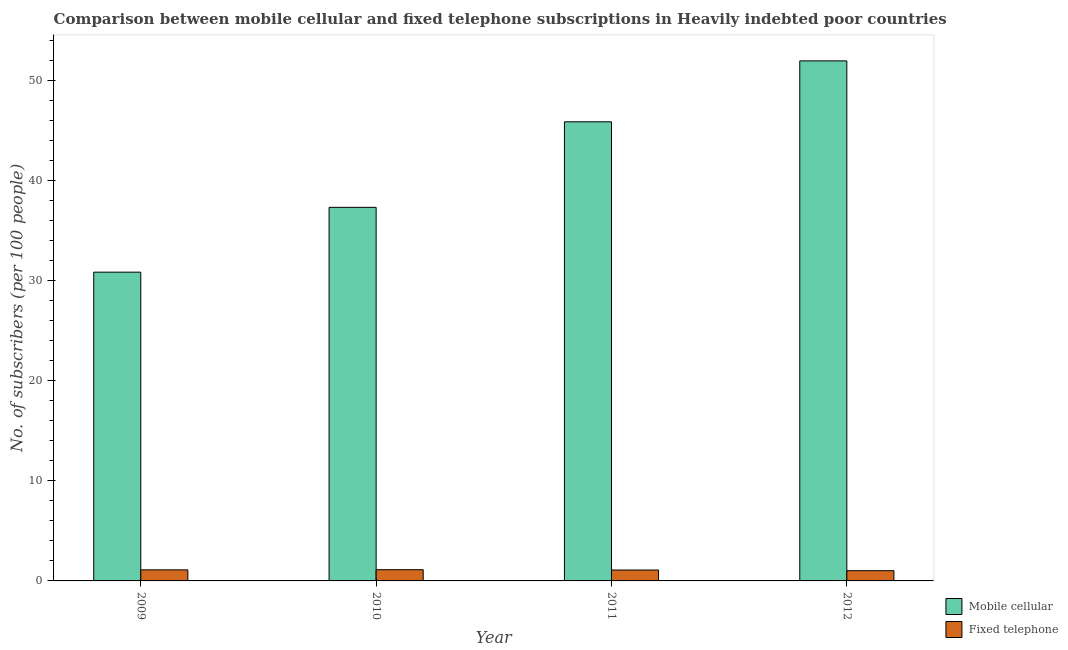How many different coloured bars are there?
Offer a terse response. 2. Are the number of bars per tick equal to the number of legend labels?
Offer a terse response. Yes. How many bars are there on the 1st tick from the left?
Give a very brief answer. 2. How many bars are there on the 3rd tick from the right?
Your response must be concise. 2. What is the label of the 4th group of bars from the left?
Provide a short and direct response. 2012. In how many cases, is the number of bars for a given year not equal to the number of legend labels?
Ensure brevity in your answer.  0. What is the number of fixed telephone subscribers in 2009?
Your answer should be compact. 1.11. Across all years, what is the maximum number of mobile cellular subscribers?
Your answer should be very brief. 51.99. Across all years, what is the minimum number of mobile cellular subscribers?
Provide a succinct answer. 30.87. In which year was the number of mobile cellular subscribers maximum?
Your answer should be very brief. 2012. What is the total number of mobile cellular subscribers in the graph?
Your answer should be very brief. 166.1. What is the difference between the number of fixed telephone subscribers in 2010 and that in 2011?
Provide a succinct answer. 0.03. What is the difference between the number of mobile cellular subscribers in 2012 and the number of fixed telephone subscribers in 2011?
Provide a short and direct response. 6.09. What is the average number of mobile cellular subscribers per year?
Your answer should be compact. 41.53. In the year 2011, what is the difference between the number of fixed telephone subscribers and number of mobile cellular subscribers?
Your response must be concise. 0. What is the ratio of the number of mobile cellular subscribers in 2009 to that in 2012?
Provide a succinct answer. 0.59. Is the difference between the number of fixed telephone subscribers in 2009 and 2012 greater than the difference between the number of mobile cellular subscribers in 2009 and 2012?
Offer a very short reply. No. What is the difference between the highest and the second highest number of fixed telephone subscribers?
Provide a short and direct response. 0.02. What is the difference between the highest and the lowest number of fixed telephone subscribers?
Give a very brief answer. 0.1. In how many years, is the number of mobile cellular subscribers greater than the average number of mobile cellular subscribers taken over all years?
Offer a very short reply. 2. What does the 1st bar from the left in 2010 represents?
Your answer should be very brief. Mobile cellular. What does the 2nd bar from the right in 2009 represents?
Make the answer very short. Mobile cellular. What is the difference between two consecutive major ticks on the Y-axis?
Your answer should be very brief. 10. Are the values on the major ticks of Y-axis written in scientific E-notation?
Provide a succinct answer. No. Does the graph contain any zero values?
Provide a short and direct response. No. Does the graph contain grids?
Your answer should be very brief. No. Where does the legend appear in the graph?
Your answer should be compact. Bottom right. How many legend labels are there?
Ensure brevity in your answer.  2. How are the legend labels stacked?
Your answer should be very brief. Vertical. What is the title of the graph?
Provide a short and direct response. Comparison between mobile cellular and fixed telephone subscriptions in Heavily indebted poor countries. Does "Highest 20% of population" appear as one of the legend labels in the graph?
Offer a terse response. No. What is the label or title of the Y-axis?
Offer a terse response. No. of subscribers (per 100 people). What is the No. of subscribers (per 100 people) of Mobile cellular in 2009?
Offer a terse response. 30.87. What is the No. of subscribers (per 100 people) in Fixed telephone in 2009?
Your response must be concise. 1.11. What is the No. of subscribers (per 100 people) in Mobile cellular in 2010?
Your response must be concise. 37.35. What is the No. of subscribers (per 100 people) of Fixed telephone in 2010?
Give a very brief answer. 1.12. What is the No. of subscribers (per 100 people) of Mobile cellular in 2011?
Your answer should be very brief. 45.9. What is the No. of subscribers (per 100 people) of Fixed telephone in 2011?
Offer a very short reply. 1.09. What is the No. of subscribers (per 100 people) in Mobile cellular in 2012?
Your answer should be compact. 51.99. What is the No. of subscribers (per 100 people) of Fixed telephone in 2012?
Provide a short and direct response. 1.02. Across all years, what is the maximum No. of subscribers (per 100 people) of Mobile cellular?
Make the answer very short. 51.99. Across all years, what is the maximum No. of subscribers (per 100 people) of Fixed telephone?
Provide a succinct answer. 1.12. Across all years, what is the minimum No. of subscribers (per 100 people) of Mobile cellular?
Give a very brief answer. 30.87. Across all years, what is the minimum No. of subscribers (per 100 people) in Fixed telephone?
Keep it short and to the point. 1.02. What is the total No. of subscribers (per 100 people) of Mobile cellular in the graph?
Give a very brief answer. 166.1. What is the total No. of subscribers (per 100 people) in Fixed telephone in the graph?
Provide a succinct answer. 4.34. What is the difference between the No. of subscribers (per 100 people) in Mobile cellular in 2009 and that in 2010?
Give a very brief answer. -6.48. What is the difference between the No. of subscribers (per 100 people) in Fixed telephone in 2009 and that in 2010?
Provide a short and direct response. -0.02. What is the difference between the No. of subscribers (per 100 people) in Mobile cellular in 2009 and that in 2011?
Ensure brevity in your answer.  -15.03. What is the difference between the No. of subscribers (per 100 people) in Fixed telephone in 2009 and that in 2011?
Offer a very short reply. 0.02. What is the difference between the No. of subscribers (per 100 people) of Mobile cellular in 2009 and that in 2012?
Your response must be concise. -21.12. What is the difference between the No. of subscribers (per 100 people) in Fixed telephone in 2009 and that in 2012?
Offer a terse response. 0.08. What is the difference between the No. of subscribers (per 100 people) in Mobile cellular in 2010 and that in 2011?
Make the answer very short. -8.55. What is the difference between the No. of subscribers (per 100 people) in Fixed telephone in 2010 and that in 2011?
Keep it short and to the point. 0.03. What is the difference between the No. of subscribers (per 100 people) in Mobile cellular in 2010 and that in 2012?
Ensure brevity in your answer.  -14.64. What is the difference between the No. of subscribers (per 100 people) in Fixed telephone in 2010 and that in 2012?
Make the answer very short. 0.1. What is the difference between the No. of subscribers (per 100 people) of Mobile cellular in 2011 and that in 2012?
Make the answer very short. -6.09. What is the difference between the No. of subscribers (per 100 people) in Fixed telephone in 2011 and that in 2012?
Provide a succinct answer. 0.07. What is the difference between the No. of subscribers (per 100 people) of Mobile cellular in 2009 and the No. of subscribers (per 100 people) of Fixed telephone in 2010?
Provide a succinct answer. 29.75. What is the difference between the No. of subscribers (per 100 people) in Mobile cellular in 2009 and the No. of subscribers (per 100 people) in Fixed telephone in 2011?
Your answer should be very brief. 29.78. What is the difference between the No. of subscribers (per 100 people) in Mobile cellular in 2009 and the No. of subscribers (per 100 people) in Fixed telephone in 2012?
Give a very brief answer. 29.84. What is the difference between the No. of subscribers (per 100 people) of Mobile cellular in 2010 and the No. of subscribers (per 100 people) of Fixed telephone in 2011?
Offer a very short reply. 36.26. What is the difference between the No. of subscribers (per 100 people) of Mobile cellular in 2010 and the No. of subscribers (per 100 people) of Fixed telephone in 2012?
Ensure brevity in your answer.  36.32. What is the difference between the No. of subscribers (per 100 people) in Mobile cellular in 2011 and the No. of subscribers (per 100 people) in Fixed telephone in 2012?
Make the answer very short. 44.88. What is the average No. of subscribers (per 100 people) in Mobile cellular per year?
Offer a terse response. 41.53. What is the average No. of subscribers (per 100 people) in Fixed telephone per year?
Keep it short and to the point. 1.08. In the year 2009, what is the difference between the No. of subscribers (per 100 people) of Mobile cellular and No. of subscribers (per 100 people) of Fixed telephone?
Provide a short and direct response. 29.76. In the year 2010, what is the difference between the No. of subscribers (per 100 people) of Mobile cellular and No. of subscribers (per 100 people) of Fixed telephone?
Give a very brief answer. 36.23. In the year 2011, what is the difference between the No. of subscribers (per 100 people) of Mobile cellular and No. of subscribers (per 100 people) of Fixed telephone?
Your answer should be compact. 44.81. In the year 2012, what is the difference between the No. of subscribers (per 100 people) in Mobile cellular and No. of subscribers (per 100 people) in Fixed telephone?
Your response must be concise. 50.97. What is the ratio of the No. of subscribers (per 100 people) in Mobile cellular in 2009 to that in 2010?
Your answer should be very brief. 0.83. What is the ratio of the No. of subscribers (per 100 people) of Fixed telephone in 2009 to that in 2010?
Your response must be concise. 0.99. What is the ratio of the No. of subscribers (per 100 people) of Mobile cellular in 2009 to that in 2011?
Make the answer very short. 0.67. What is the ratio of the No. of subscribers (per 100 people) of Fixed telephone in 2009 to that in 2011?
Provide a short and direct response. 1.02. What is the ratio of the No. of subscribers (per 100 people) of Mobile cellular in 2009 to that in 2012?
Ensure brevity in your answer.  0.59. What is the ratio of the No. of subscribers (per 100 people) in Fixed telephone in 2009 to that in 2012?
Provide a short and direct response. 1.08. What is the ratio of the No. of subscribers (per 100 people) of Mobile cellular in 2010 to that in 2011?
Provide a succinct answer. 0.81. What is the ratio of the No. of subscribers (per 100 people) in Mobile cellular in 2010 to that in 2012?
Offer a terse response. 0.72. What is the ratio of the No. of subscribers (per 100 people) of Fixed telephone in 2010 to that in 2012?
Your answer should be very brief. 1.1. What is the ratio of the No. of subscribers (per 100 people) in Mobile cellular in 2011 to that in 2012?
Ensure brevity in your answer.  0.88. What is the ratio of the No. of subscribers (per 100 people) of Fixed telephone in 2011 to that in 2012?
Offer a very short reply. 1.06. What is the difference between the highest and the second highest No. of subscribers (per 100 people) of Mobile cellular?
Provide a short and direct response. 6.09. What is the difference between the highest and the second highest No. of subscribers (per 100 people) of Fixed telephone?
Your answer should be compact. 0.02. What is the difference between the highest and the lowest No. of subscribers (per 100 people) in Mobile cellular?
Your answer should be very brief. 21.12. What is the difference between the highest and the lowest No. of subscribers (per 100 people) of Fixed telephone?
Keep it short and to the point. 0.1. 